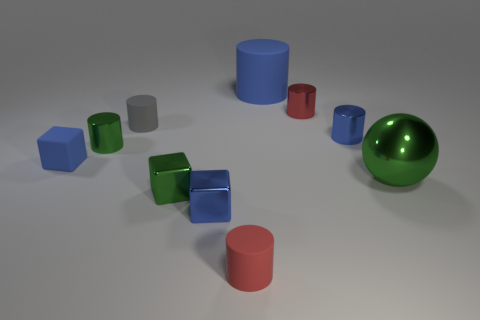There is a cube that is the same color as the big metal thing; what is its size?
Your response must be concise. Small. There is a blue object that is on the right side of the small red thing behind the tiny blue rubber cube; what is it made of?
Your answer should be very brief. Metal. Is the number of small green cylinders that are in front of the large blue rubber cylinder less than the number of things that are behind the gray cylinder?
Offer a very short reply. Yes. How many blue objects are large balls or blocks?
Give a very brief answer. 2. Are there an equal number of tiny red rubber objects in front of the large blue cylinder and large cyan cubes?
Ensure brevity in your answer.  No. What number of things are red rubber cylinders or small blue shiny objects that are right of the blue shiny cube?
Offer a terse response. 2. Do the matte block and the large cylinder have the same color?
Your answer should be very brief. Yes. Is there a tiny block made of the same material as the green ball?
Give a very brief answer. Yes. There is another tiny rubber object that is the same shape as the small red rubber thing; what color is it?
Your answer should be compact. Gray. Do the small blue cylinder and the small red thing that is in front of the tiny blue matte block have the same material?
Ensure brevity in your answer.  No. 